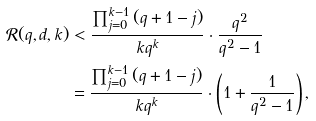<formula> <loc_0><loc_0><loc_500><loc_500>\mathcal { R } ( q , d , k ) & < \frac { \prod _ { j = 0 } ^ { k - 1 } { ( q + 1 - j ) } } { k q ^ { k } } \cdot \frac { q ^ { 2 } } { q ^ { 2 } - 1 } \\ & = \frac { \prod _ { j = 0 } ^ { k - 1 } { ( q + 1 - j ) } } { k q ^ { k } } \cdot \left ( 1 + \frac { 1 } { q ^ { 2 } - 1 } \right ) ,</formula> 